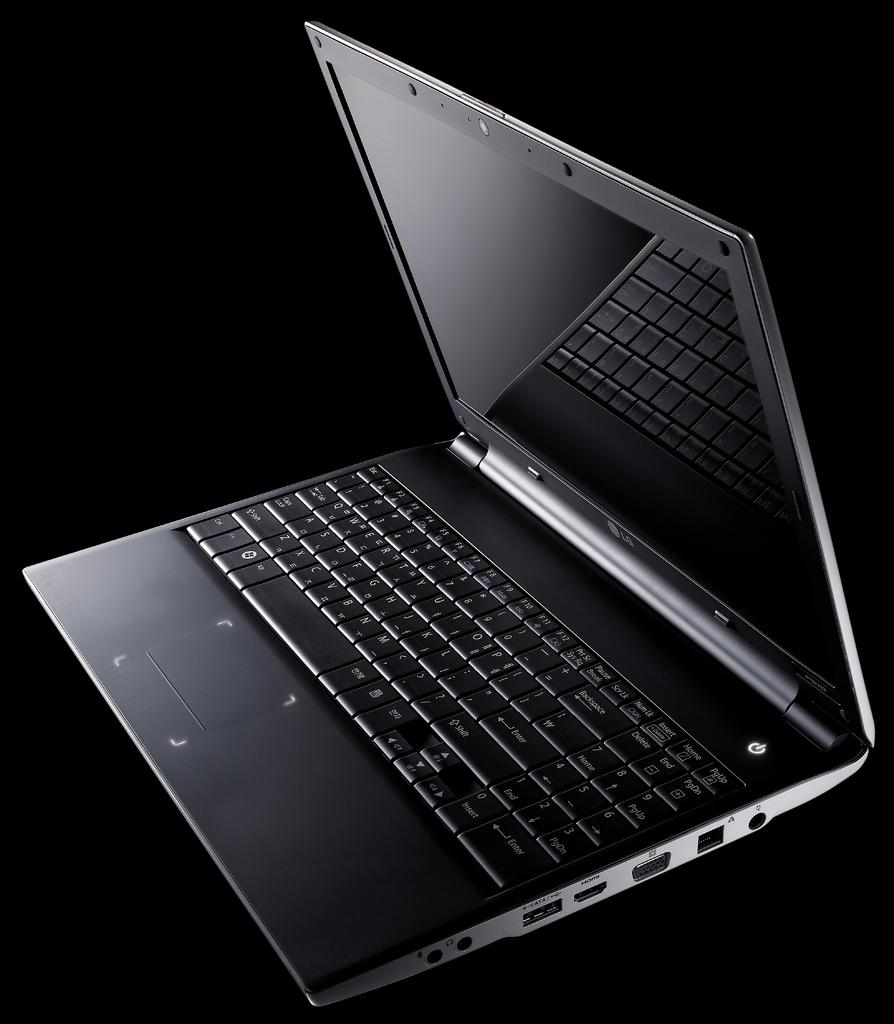Does this have an enter key?
Provide a succinct answer. Yes. What is one of the letters this keyboard has?
Keep it short and to the point. A. 